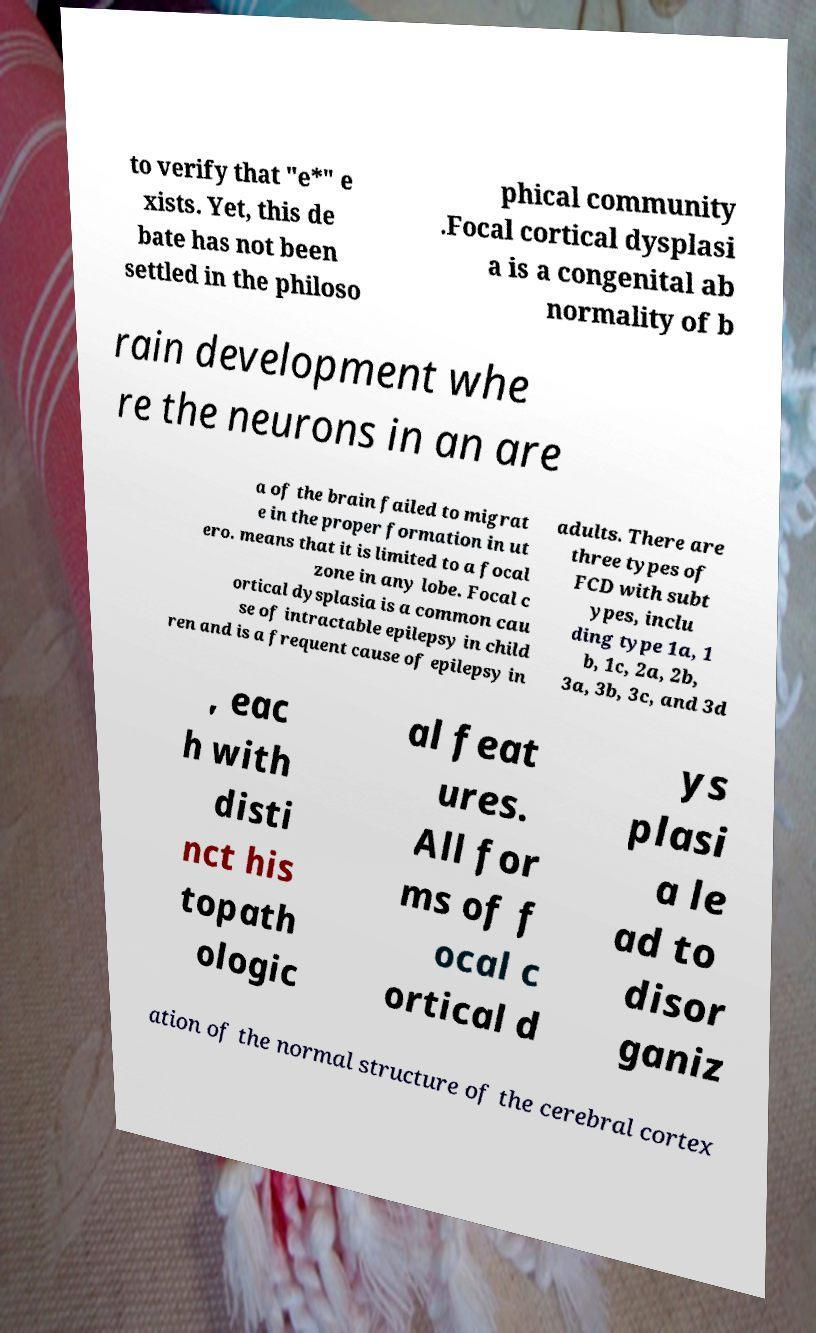Can you accurately transcribe the text from the provided image for me? to verify that "e*" e xists. Yet, this de bate has not been settled in the philoso phical community .Focal cortical dysplasi a is a congenital ab normality of b rain development whe re the neurons in an are a of the brain failed to migrat e in the proper formation in ut ero. means that it is limited to a focal zone in any lobe. Focal c ortical dysplasia is a common cau se of intractable epilepsy in child ren and is a frequent cause of epilepsy in adults. There are three types of FCD with subt ypes, inclu ding type 1a, 1 b, 1c, 2a, 2b, 3a, 3b, 3c, and 3d , eac h with disti nct his topath ologic al feat ures. All for ms of f ocal c ortical d ys plasi a le ad to disor ganiz ation of the normal structure of the cerebral cortex 